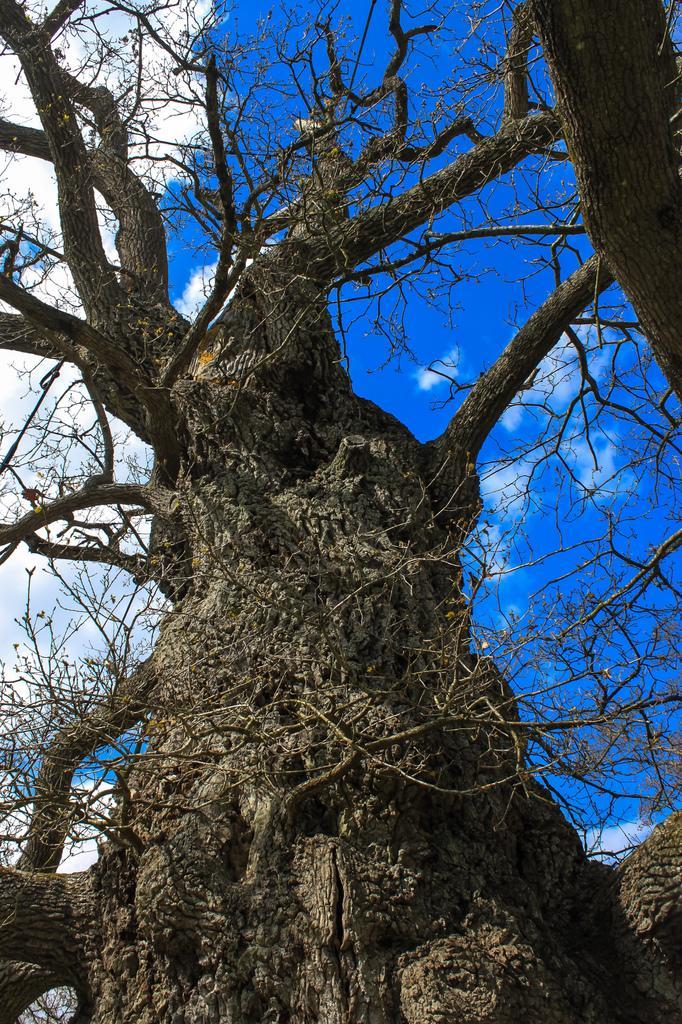In one or two sentences, can you explain what this image depicts? In this picture we can see a tree in the front, in the background we can see the sky and clouds. 